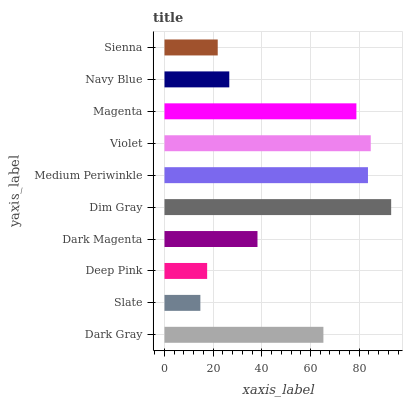Is Slate the minimum?
Answer yes or no. Yes. Is Dim Gray the maximum?
Answer yes or no. Yes. Is Deep Pink the minimum?
Answer yes or no. No. Is Deep Pink the maximum?
Answer yes or no. No. Is Deep Pink greater than Slate?
Answer yes or no. Yes. Is Slate less than Deep Pink?
Answer yes or no. Yes. Is Slate greater than Deep Pink?
Answer yes or no. No. Is Deep Pink less than Slate?
Answer yes or no. No. Is Dark Gray the high median?
Answer yes or no. Yes. Is Dark Magenta the low median?
Answer yes or no. Yes. Is Dim Gray the high median?
Answer yes or no. No. Is Sienna the low median?
Answer yes or no. No. 